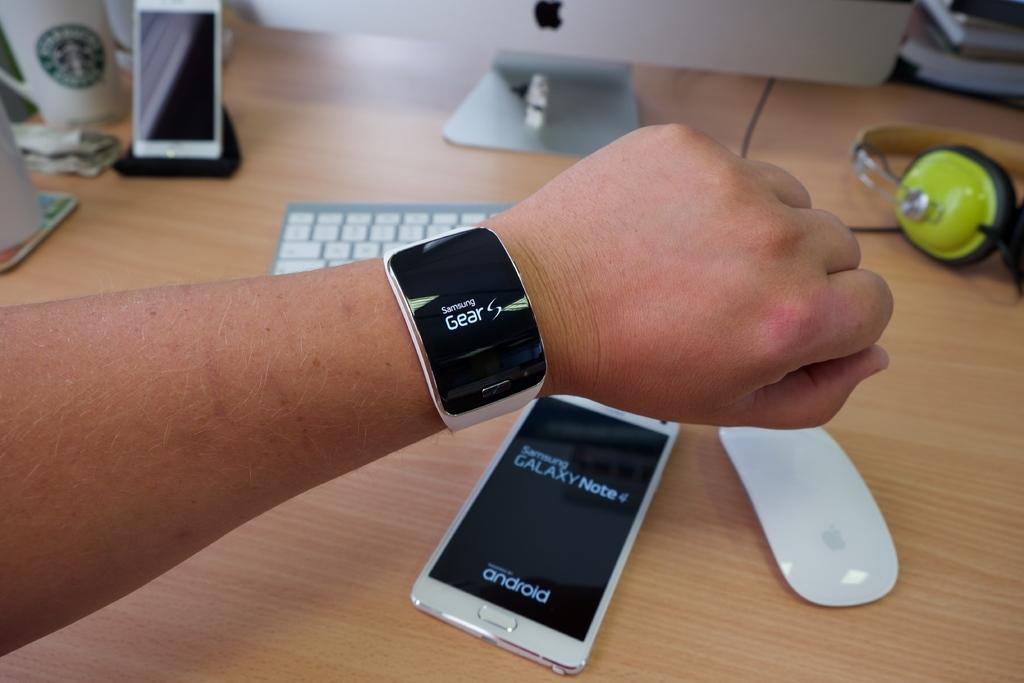<image>
Provide a brief description of the given image. A white android phone says "Samsung Galaxy Note" on the screen. 